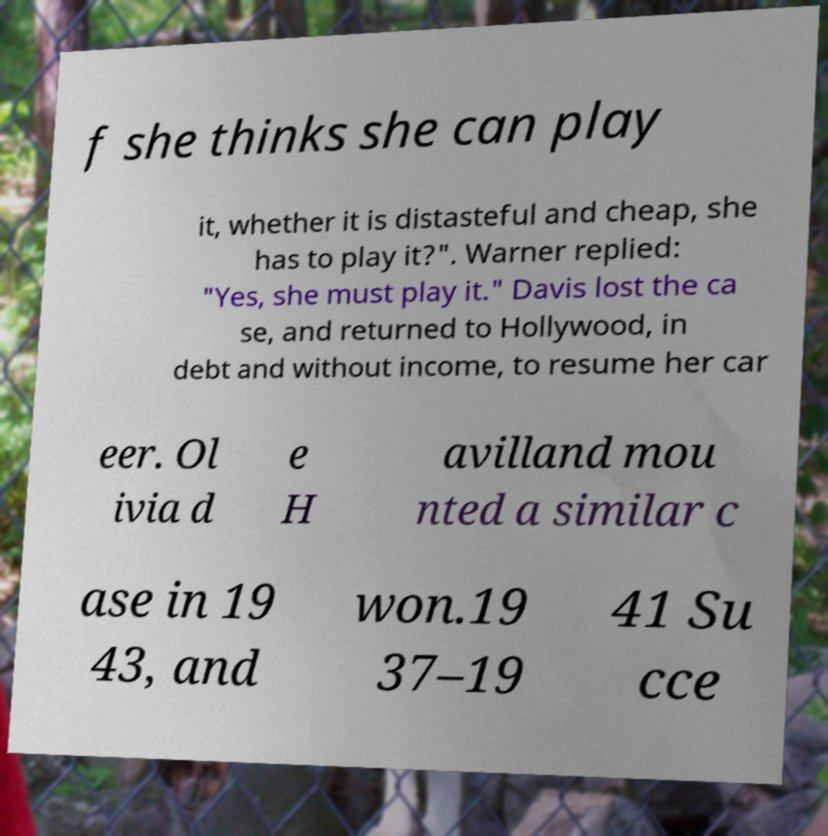Please identify and transcribe the text found in this image. f she thinks she can play it, whether it is distasteful and cheap, she has to play it?". Warner replied: "Yes, she must play it." Davis lost the ca se, and returned to Hollywood, in debt and without income, to resume her car eer. Ol ivia d e H avilland mou nted a similar c ase in 19 43, and won.19 37–19 41 Su cce 